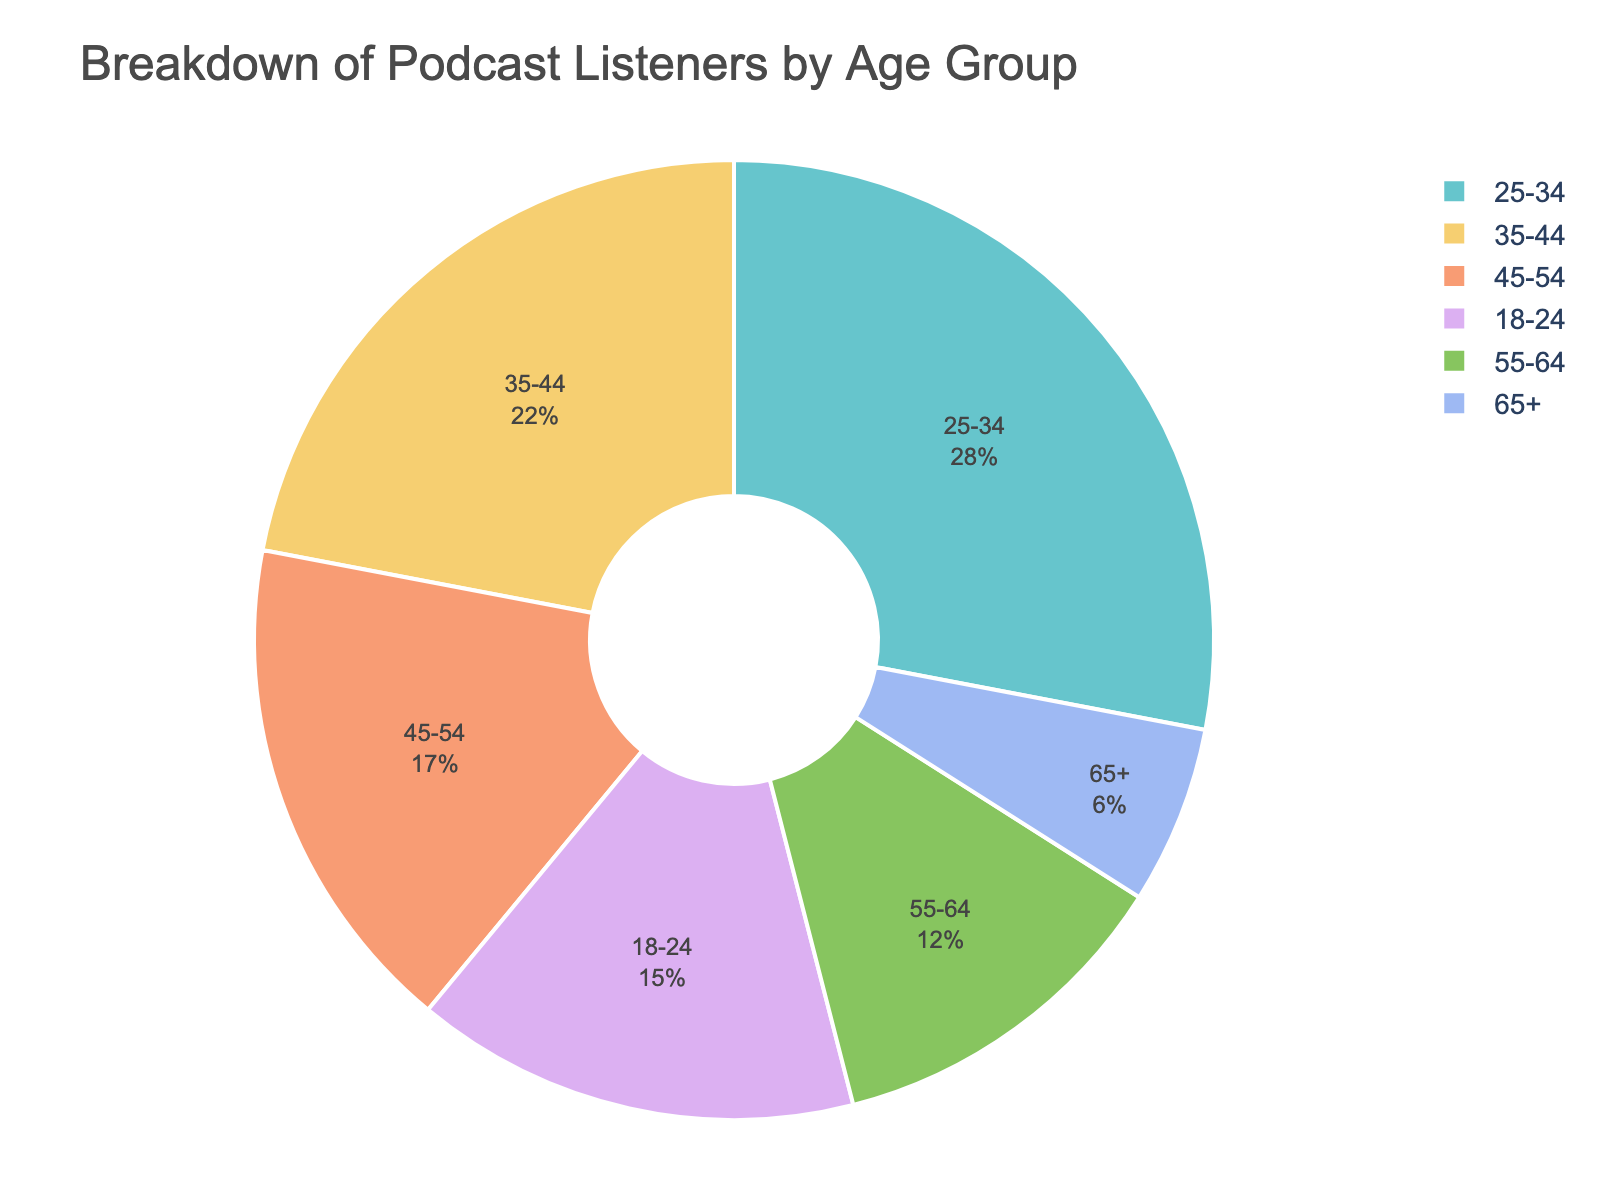What age group has the highest percentage of podcast listeners? By observing the pie chart, the segment representing the age group 25-34 appears the largest, indicating the highest percentage of listeners.
Answer: 25-34 Which age group has the smallest percentage of podcast listeners? The smallest segment in the pie chart corresponds to the age group 65+, indicating it has the smallest percentage of listeners.
Answer: 65+ What is the combined percentage of podcast listeners for the age groups 18-24 and 25-34? The percentage for 18-24 is 15%, and for 25-34 is 28%. Adding these gives 15% + 28% = 43%.
Answer: 43% Which two age groups combined make up more than 40% of the podcast listeners? Adding the percentages of each pair of age groups, the pairs 18-24 and 25-34 (15% + 28% = 43%) and 25-34 and 35-44 (28% + 22% = 50%) both exceed 40%.
Answer: 18-24 and 25-34, 25-34 and 35-44 Compare the percentage of listeners aged 45-54 to those aged 55-64. Which group is larger and by how much? The percentage for 45-54 is 17%, and for 55-64 it is 12%. Subtracting these values gives 17% - 12% = 5%. The 45-54 age group is larger by 5%.
Answer: 45-54; 5% What is the visual appearance (color) of the segment representing the age group with the second-highest percentage of listeners? The second-largest segment on the pie chart represents the age group 35-44 and is displayed using a distinctive color from the Pastel palette used.
Answer: Pastel color (can mention the specific color if visible on the chart) Calculate the average percentage of listeners for the age groups 18-24, 35-44, and 55-64. The percentages are 15%, 22%, and 12%, respectively. Summing these gives 15% + 22% + 12% = 49%. Dividing by 3 gives 49% / 3 ≈ 16.33%.
Answer: 16.33% Which age groups combined form exactly half of the podcast listeners? Summing the percentages for different combinations, the pair 35-44 and 45-54 (22% + 17% = 39%) is closest to half but not exact. Another pair, such as 25-34 and 55-64 (28% + 12% = 40%), is also not exact. No exact pairs form 50%.
Answer: No exact pairs What percentage of the podcast listeners are aged 25-54? The percentages for 25-34, 35-44, and 45-54 are 28%, 22%, and 17%, respectively. Adding these gives 28% + 22% + 17% = 67%.
Answer: 67% If you combine the youngest and oldest age groups, what percentage of the total does this account for? The percentage for 18-24 is 15%, and for 65+ it is 6%. Together, this sums up to 15% + 6% = 21%.
Answer: 21% 